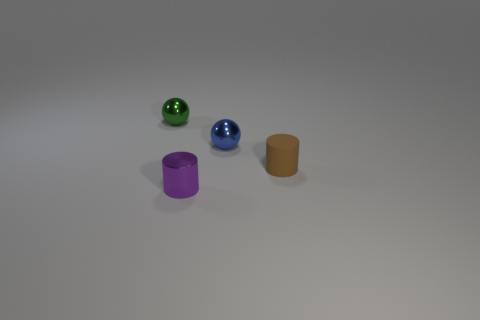What kind of lighting is used in this scene to create the shadows? The scene is lit in such a way that suggests a single diffused light source positioned above the objects, casting soft-edged shadows on the surface towards the right, which indicates its direction. 